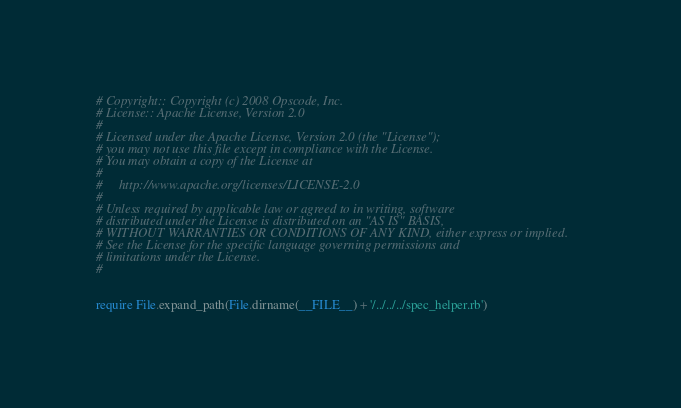Convert code to text. <code><loc_0><loc_0><loc_500><loc_500><_Ruby_># Copyright:: Copyright (c) 2008 Opscode, Inc.
# License:: Apache License, Version 2.0
#
# Licensed under the Apache License, Version 2.0 (the "License");
# you may not use this file except in compliance with the License.
# You may obtain a copy of the License at
# 
#     http://www.apache.org/licenses/LICENSE-2.0
# 
# Unless required by applicable law or agreed to in writing, software
# distributed under the License is distributed on an "AS IS" BASIS,
# WITHOUT WARRANTIES OR CONDITIONS OF ANY KIND, either express or implied.
# See the License for the specific language governing permissions and
# limitations under the License.
#


require File.expand_path(File.dirname(__FILE__) + '/../../../spec_helper.rb')
</code> 